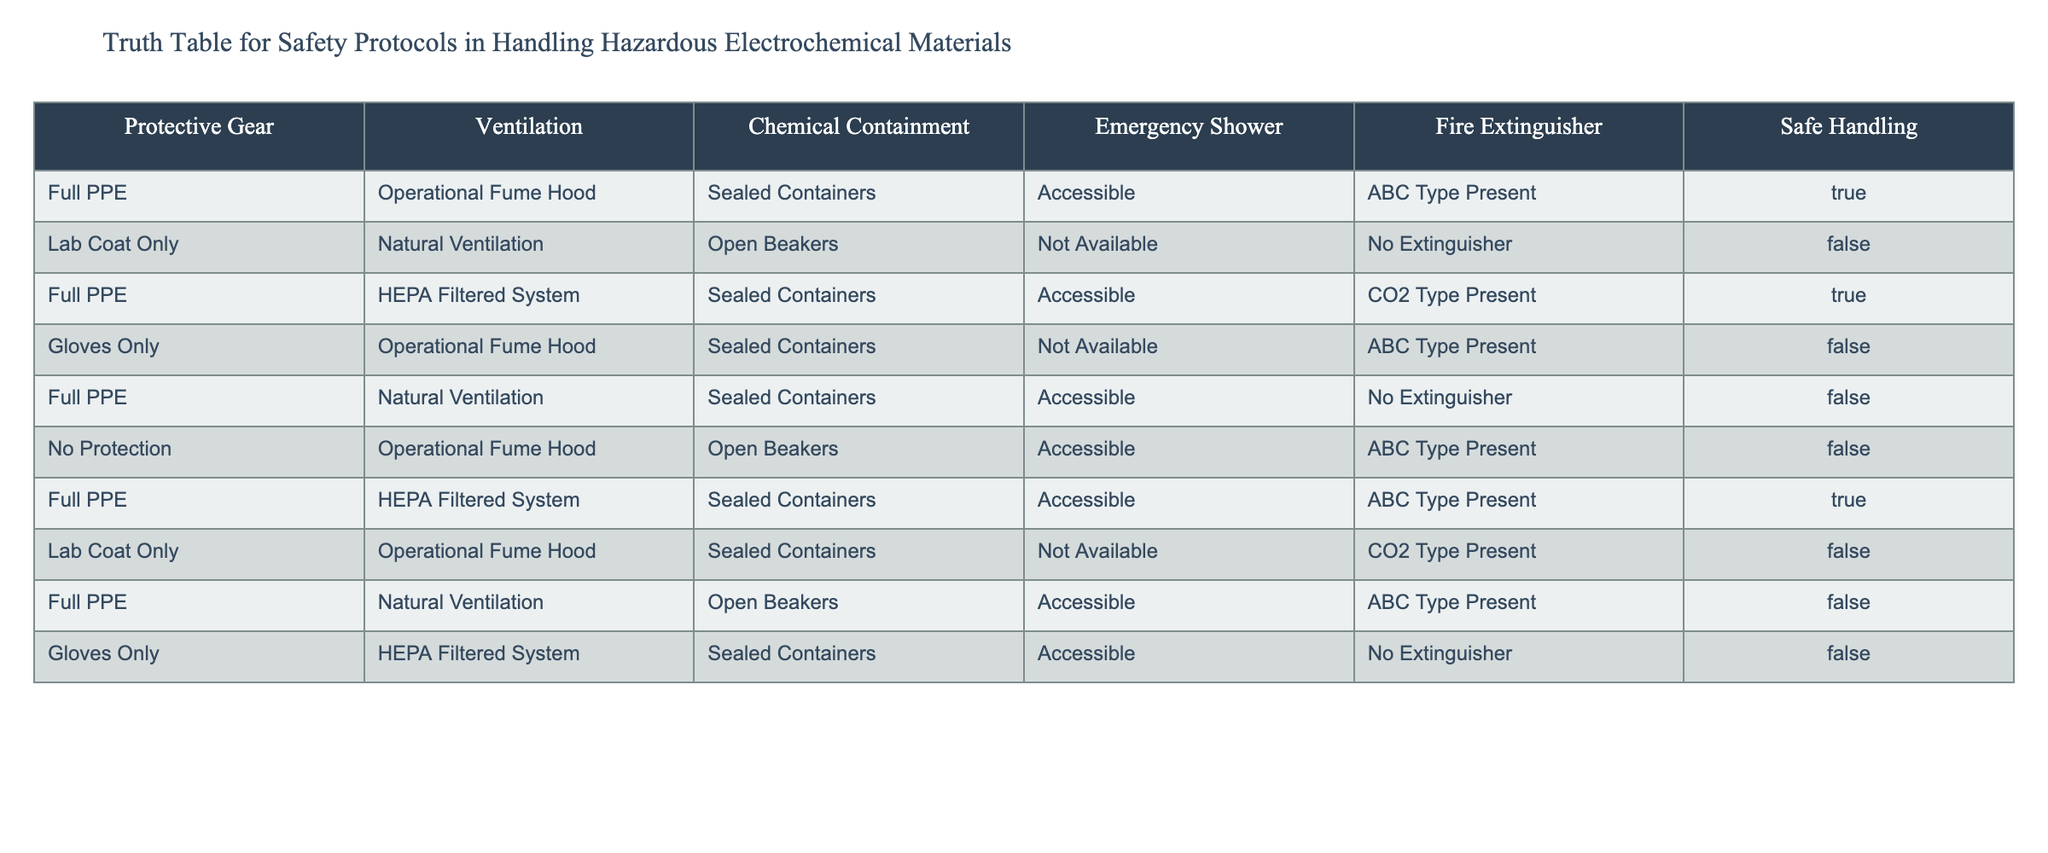What is the safe handling status when Full PPE and an Operational Fume Hood are used? In the row where Protective Gear is "Full PPE" and Ventilation is "Operational Fume Hood", the Safe Handling column shows TRUE. Hence, the safe handling status in this case is TRUE.
Answer: TRUE How many scenarios involve using Full PPE? By reviewing the table, there are three rows where Protective Gear is "Full PPE". The count is thus 3.
Answer: 3 Are there any scenarios with Lab Coat Only that provide Safe Handling? There are two cases with "Lab Coat Only". Both have FALSE in the Safe Handling status indicating that neither scenario offers safe handling.
Answer: FALSE What is the total number of scenarios with Sealed Containers and Safe Handling? In the table, observe that among the rows with "Sealed Containers", three of them have a TRUE status for Safe Handling, leading to a total of 3 scenarios where both conditions are satisfied.
Answer: 3 Which protective gear had the highest number of unsafe handling scenarios? By examining the table, the "Gloves Only" category has two instances of unsafe handling (FALSE). This is the maximum among the different protective gear categories.
Answer: Gloves Only 